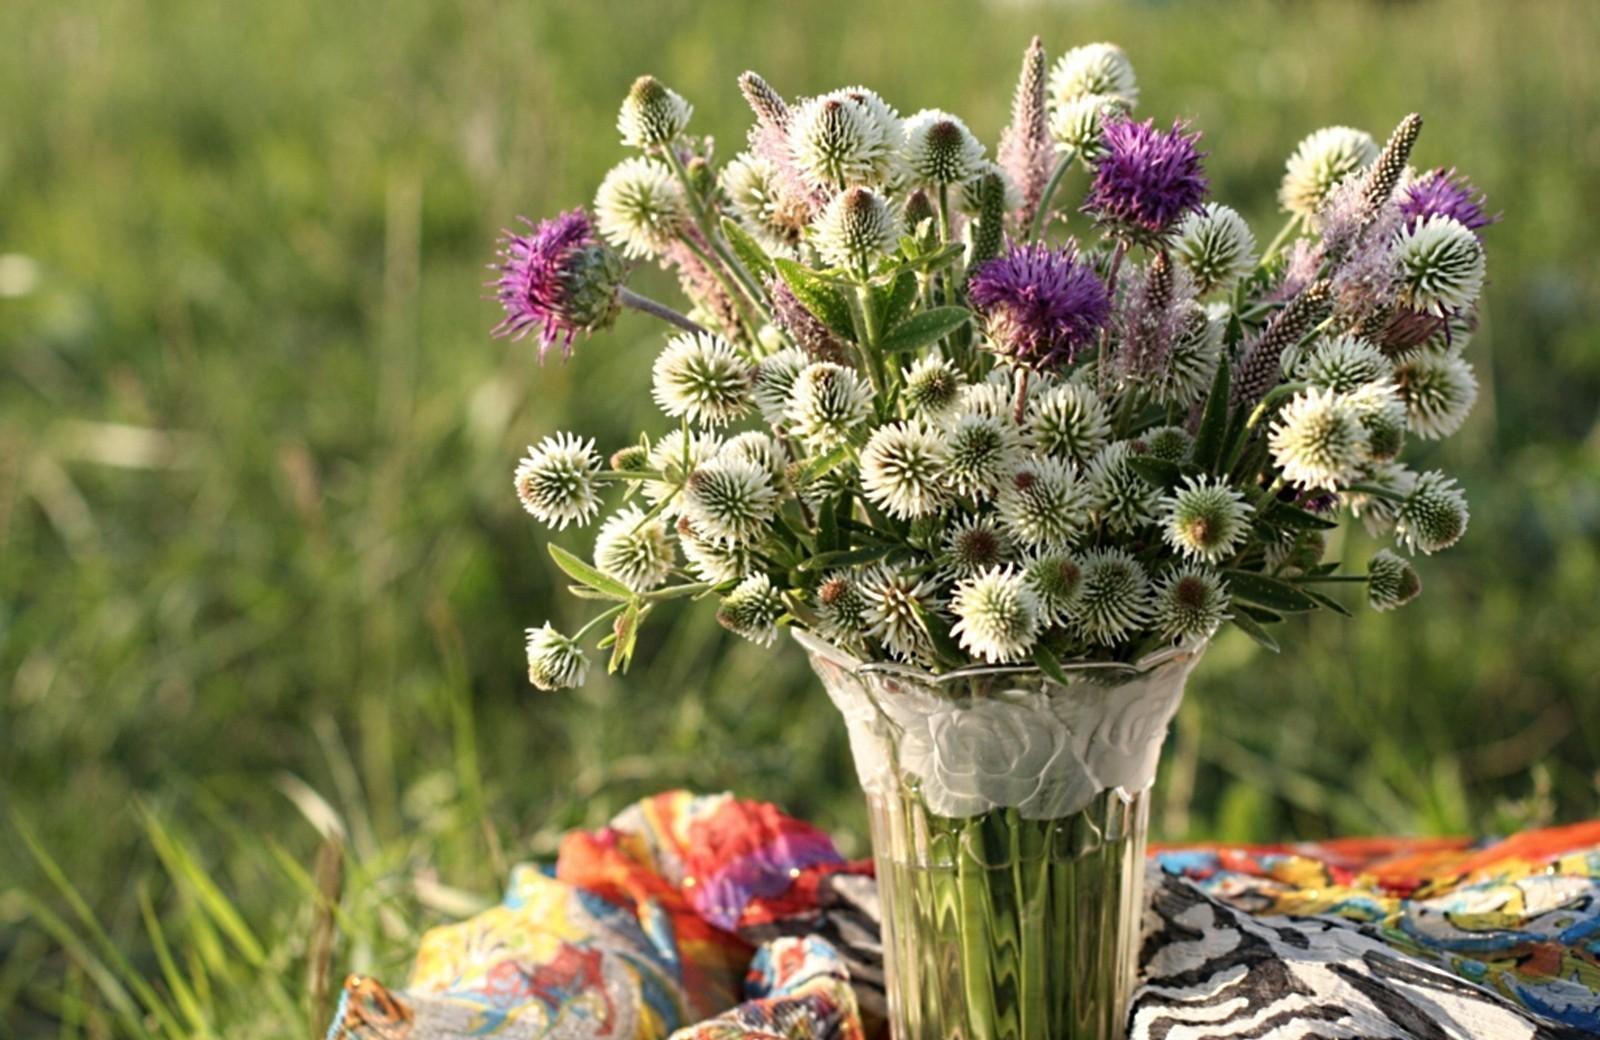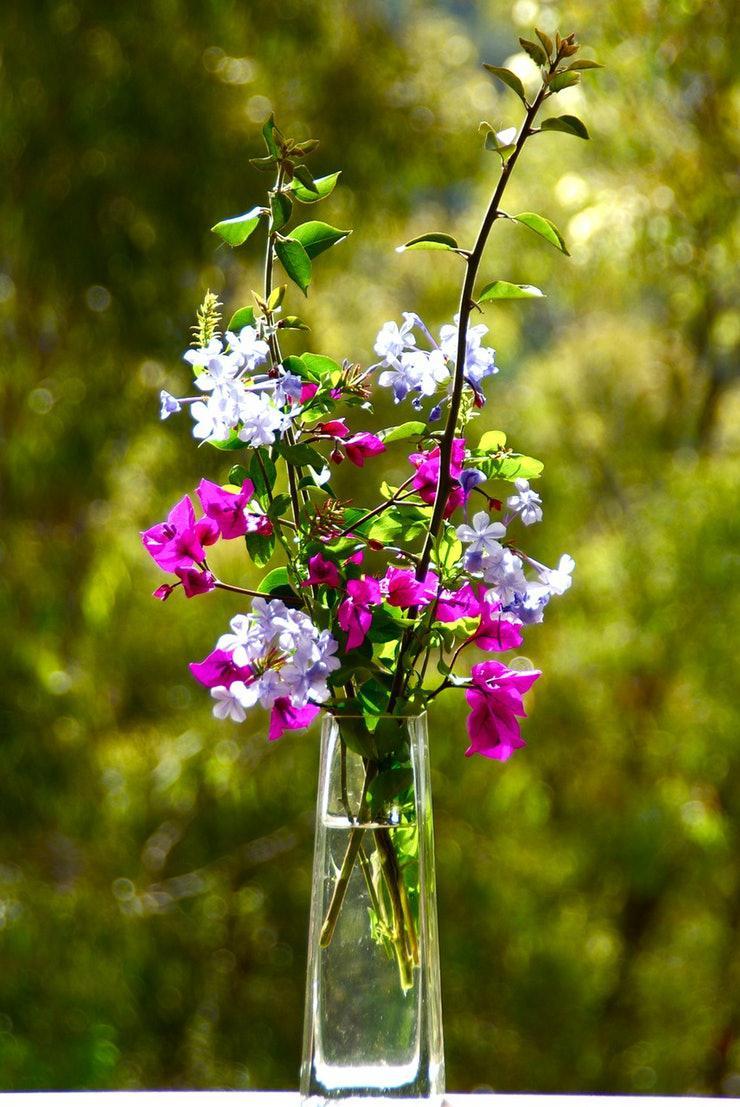The first image is the image on the left, the second image is the image on the right. Evaluate the accuracy of this statement regarding the images: "At least one vase is hanging.". Is it true? Answer yes or no. No. 